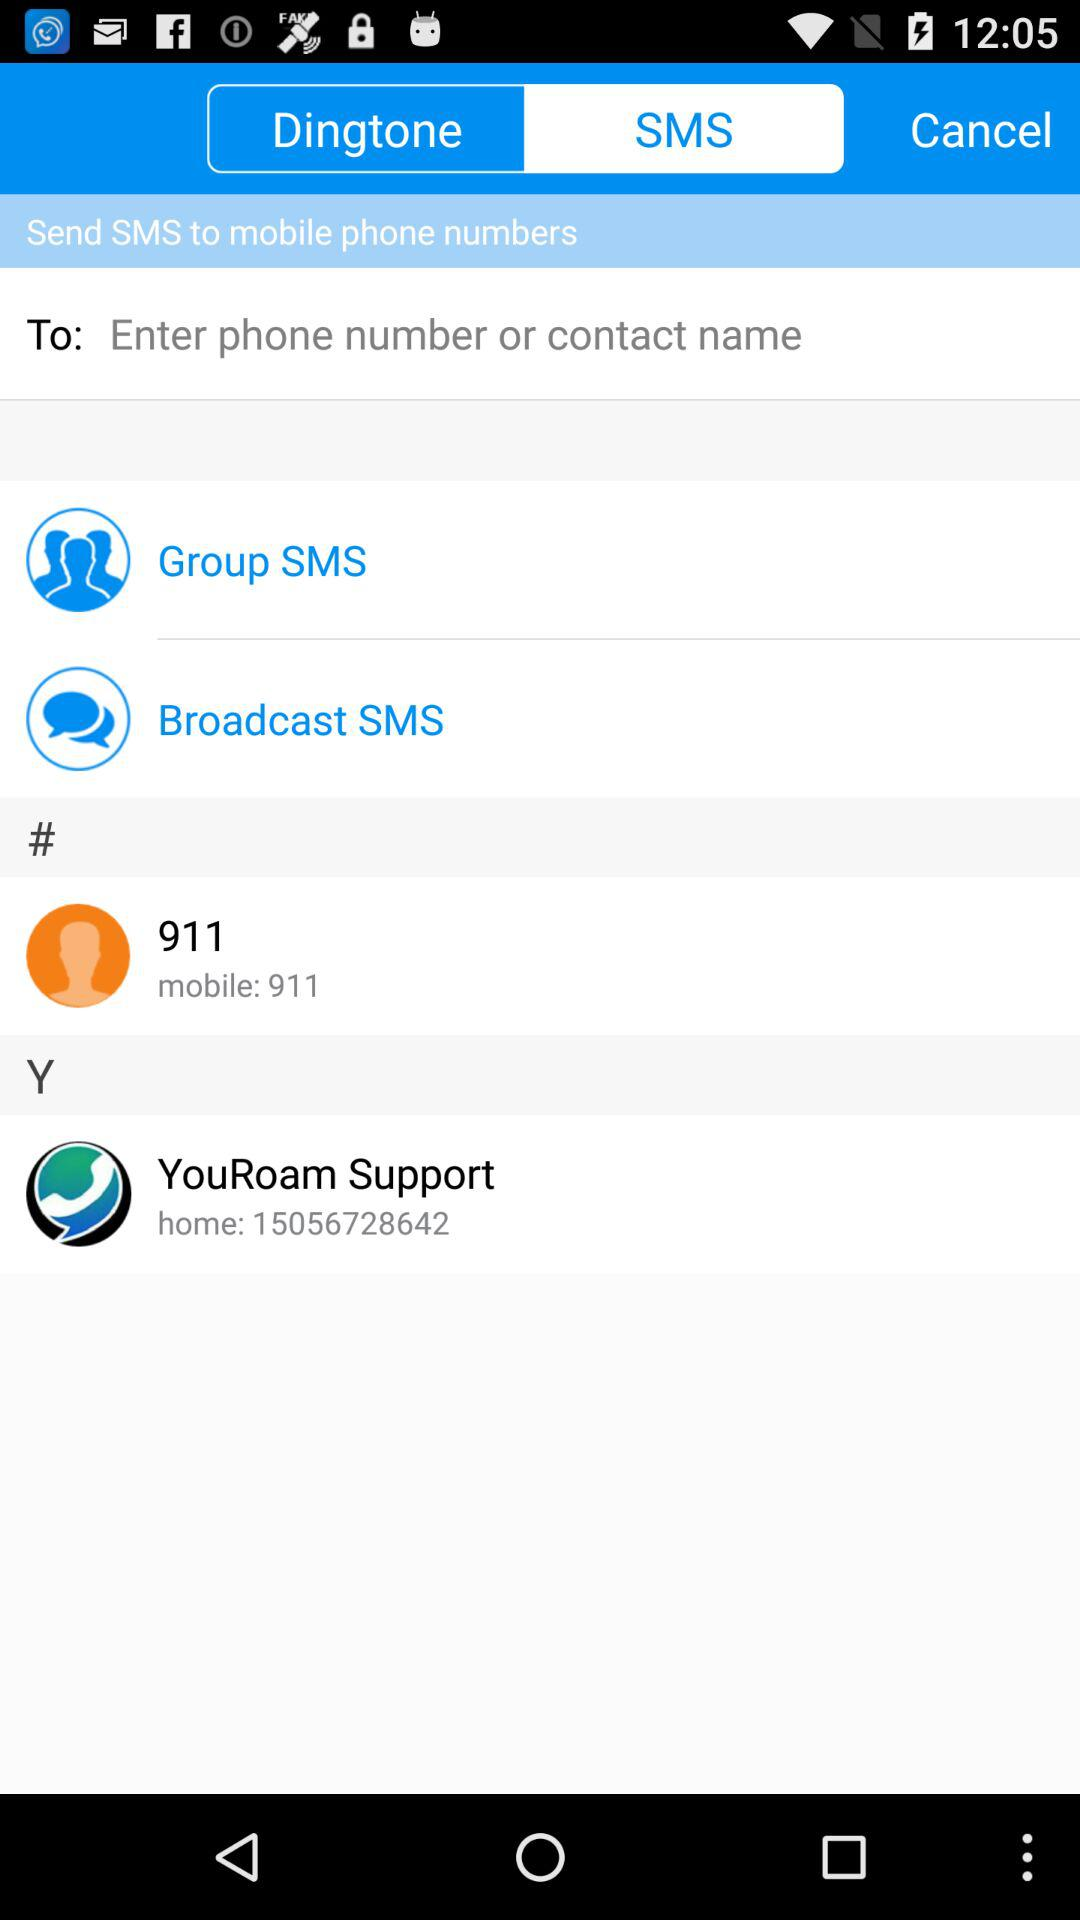What is the "YouRoam" support number? The "YouRoam" support number is 15056728642. 